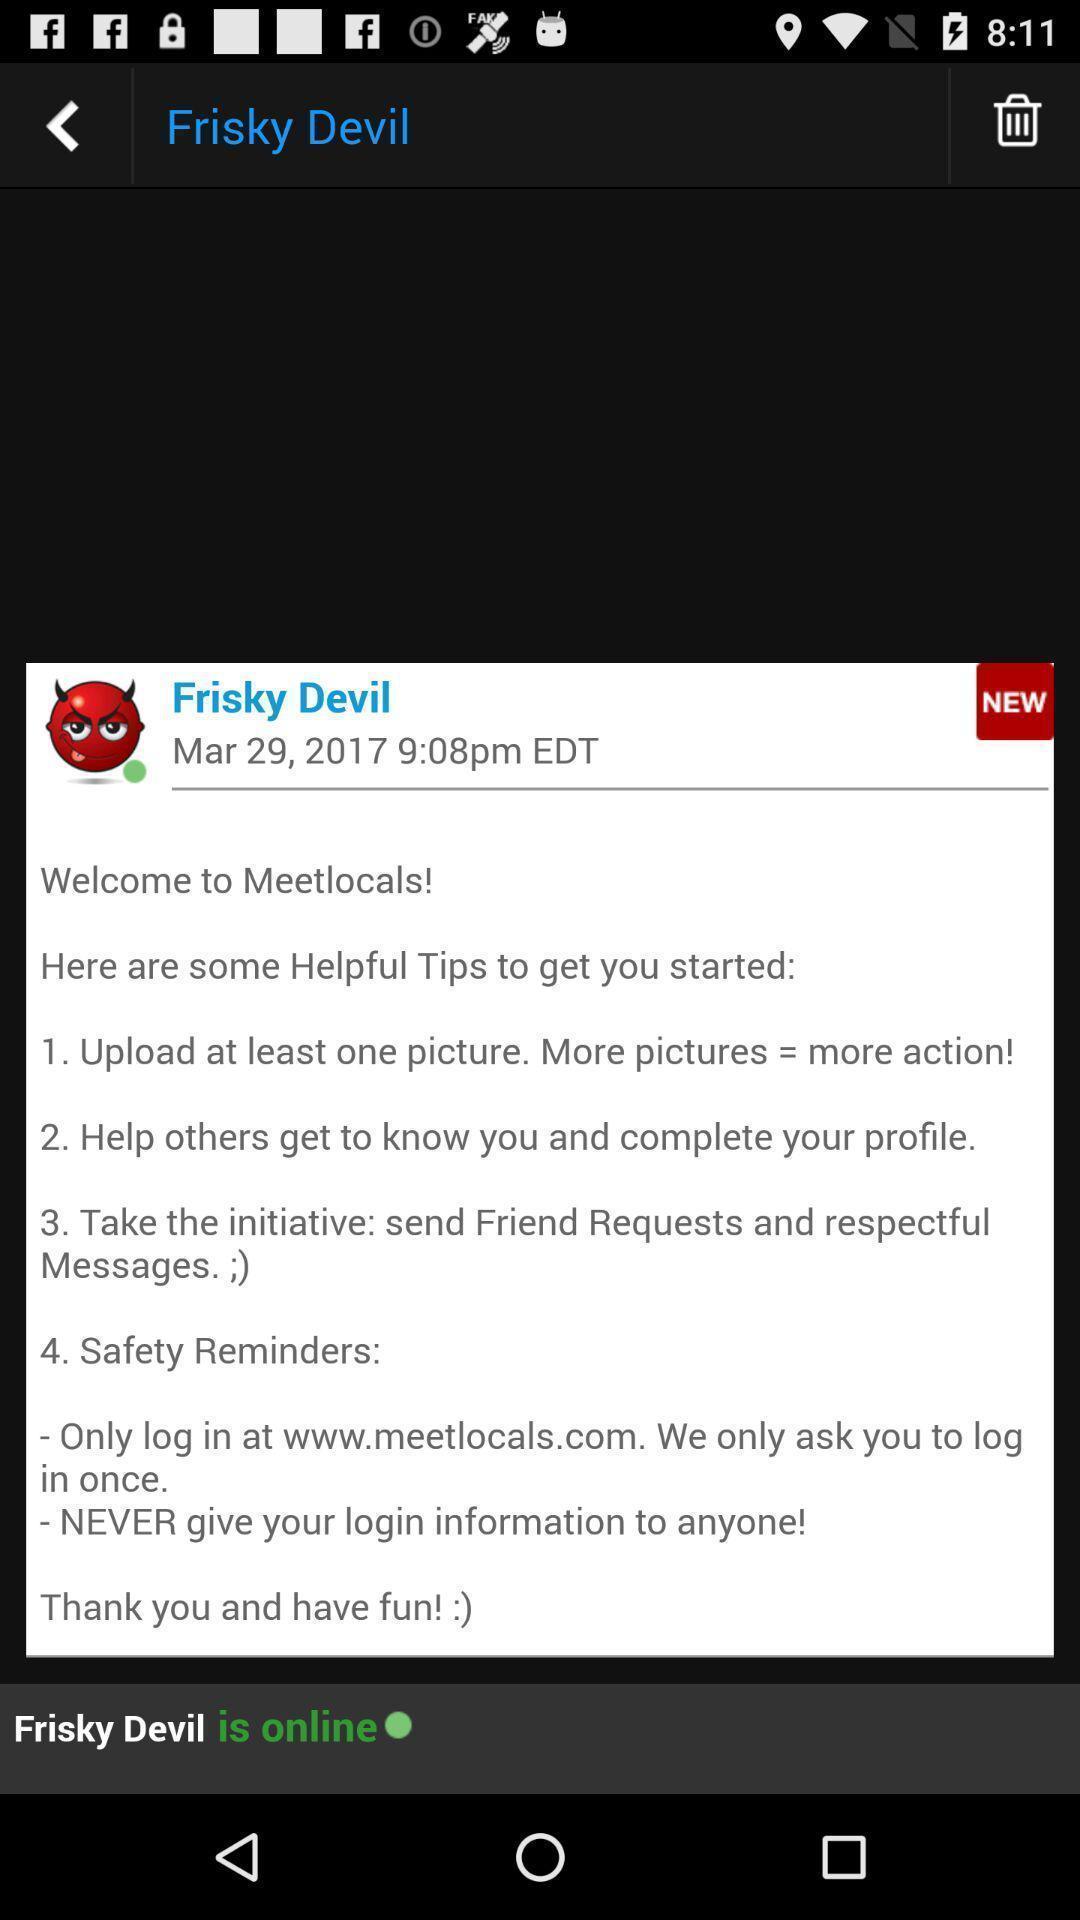Give me a narrative description of this picture. Welcome page of a messaging app. 